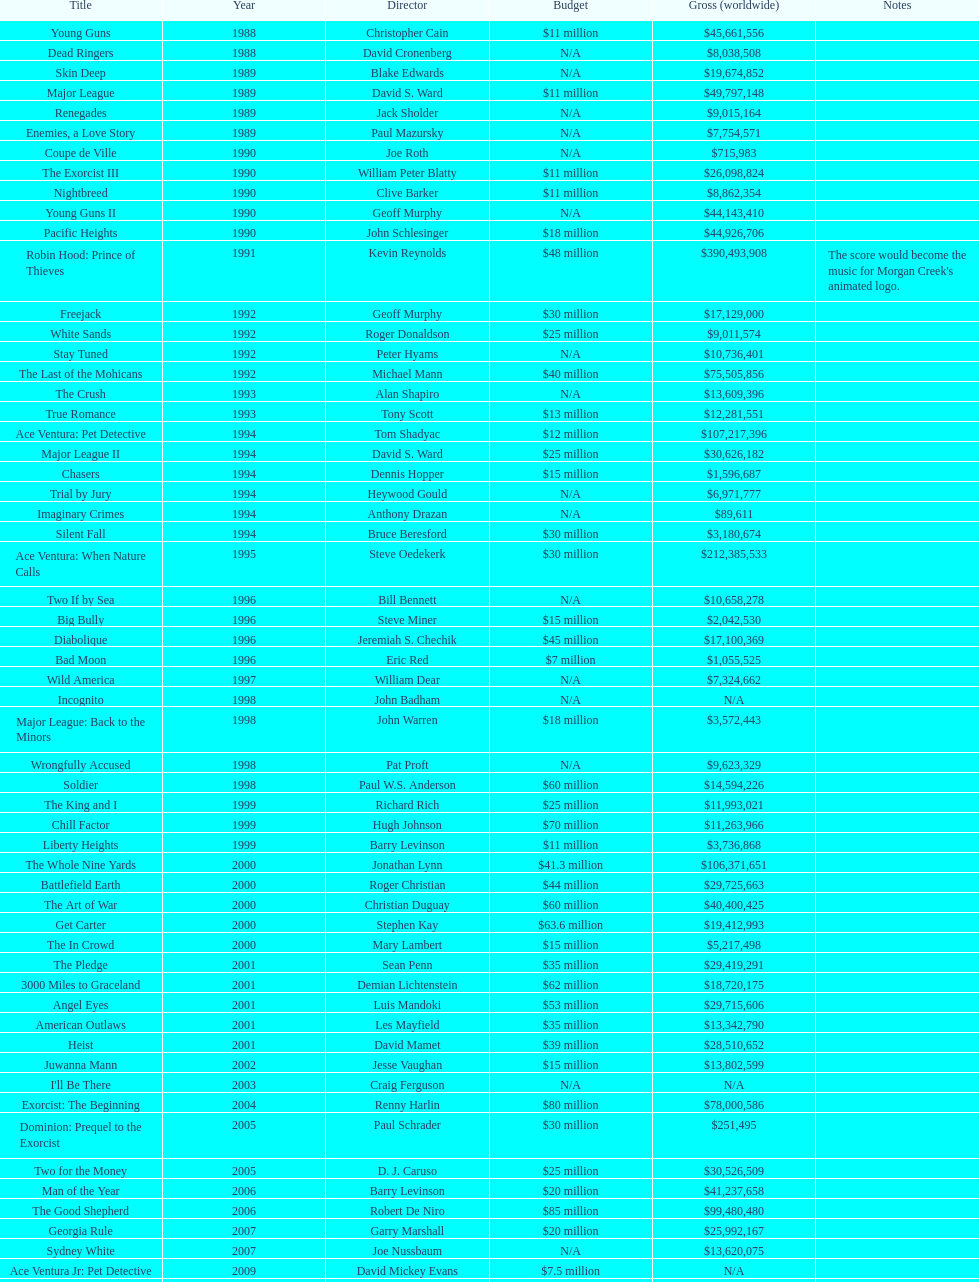Which movie made more money, true romance or diabolique? Less. 